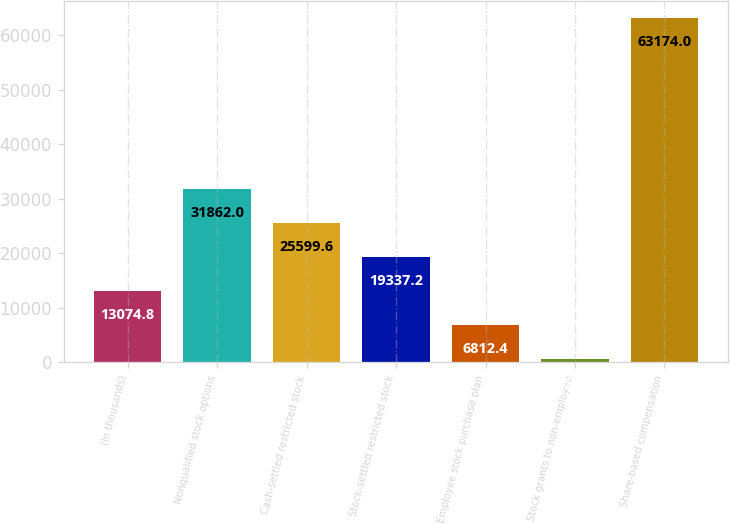Convert chart to OTSL. <chart><loc_0><loc_0><loc_500><loc_500><bar_chart><fcel>(In thousands)<fcel>Nonqualified stock options<fcel>Cash-settled restricted stock<fcel>Stock-settled restricted stock<fcel>Employee stock purchase plan<fcel>Stock grants to non-employee<fcel>Share-based compensation<nl><fcel>13074.8<fcel>31862<fcel>25599.6<fcel>19337.2<fcel>6812.4<fcel>550<fcel>63174<nl></chart> 